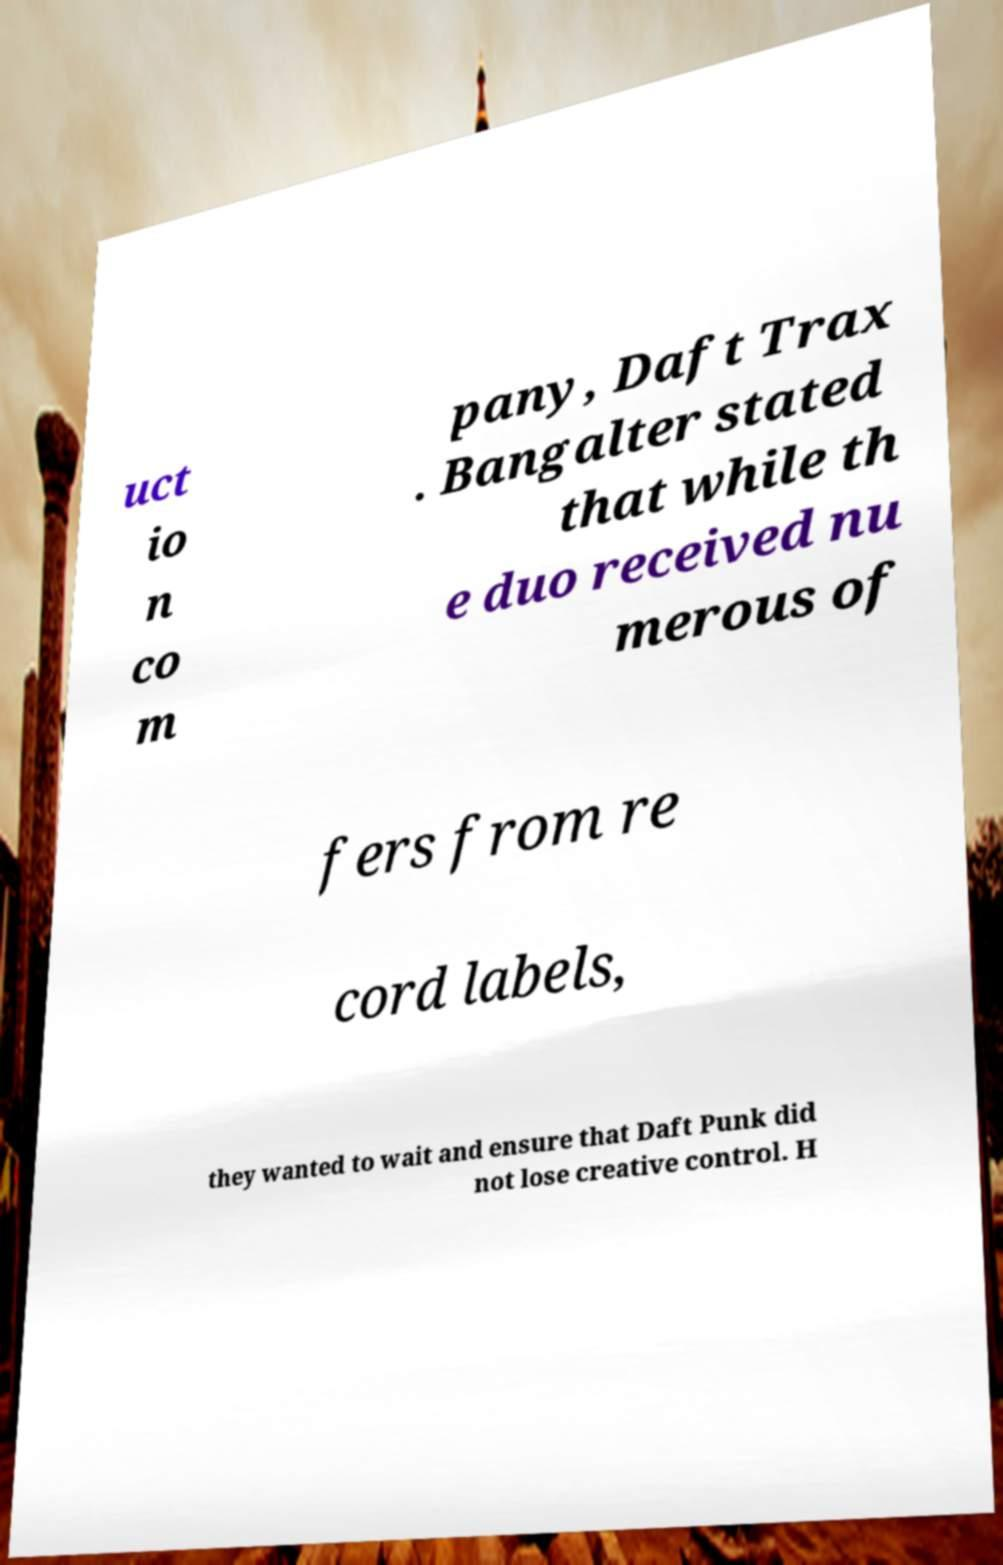Please identify and transcribe the text found in this image. uct io n co m pany, Daft Trax . Bangalter stated that while th e duo received nu merous of fers from re cord labels, they wanted to wait and ensure that Daft Punk did not lose creative control. H 